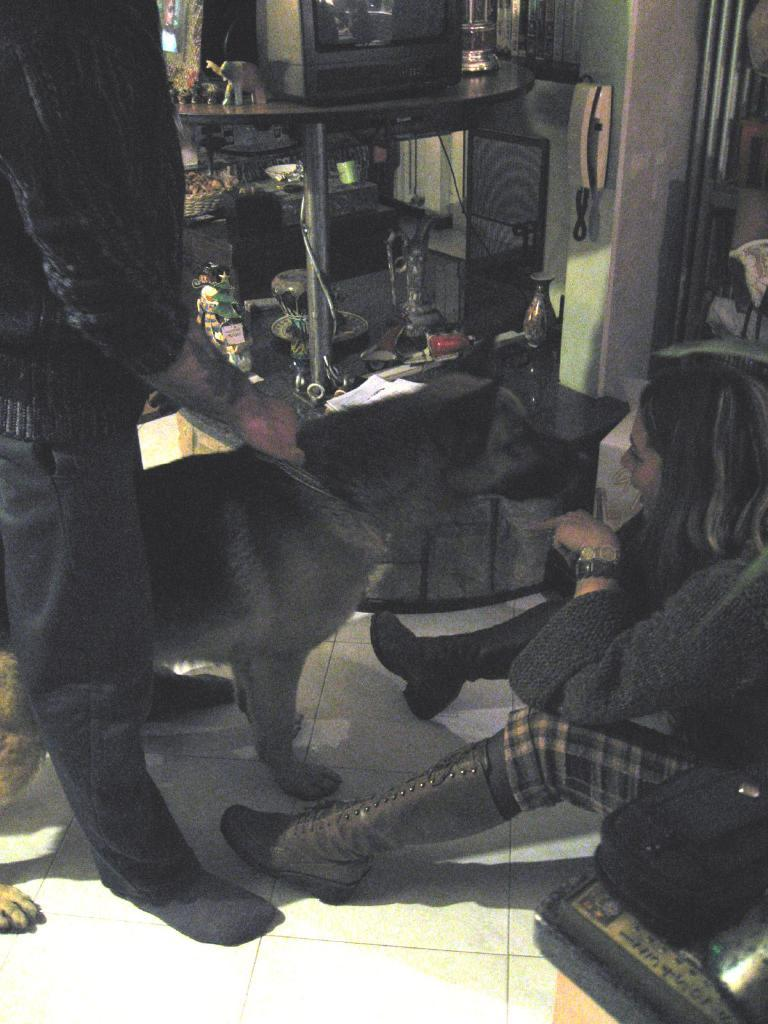What type of animal is present in the image? There is a dog in the image. How many people are in the image? There are two persons in the image. What is the surface that the dog and people are standing on? The image shows a floor. What can be seen in the background of the image? There is a television, toys, a phone, and a table in the background of the image. What type of street is visible in the image? There is no street visible in the image; it shows a floor and background objects. What type of scissors are being used by the dog in the image? There are no scissors present in the image, and the dog is not using any tools. 